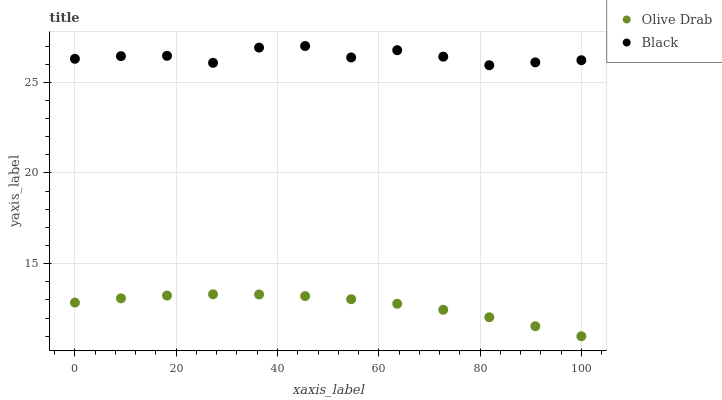Does Olive Drab have the minimum area under the curve?
Answer yes or no. Yes. Does Black have the maximum area under the curve?
Answer yes or no. Yes. Does Olive Drab have the maximum area under the curve?
Answer yes or no. No. Is Olive Drab the smoothest?
Answer yes or no. Yes. Is Black the roughest?
Answer yes or no. Yes. Is Olive Drab the roughest?
Answer yes or no. No. Does Olive Drab have the lowest value?
Answer yes or no. Yes. Does Black have the highest value?
Answer yes or no. Yes. Does Olive Drab have the highest value?
Answer yes or no. No. Is Olive Drab less than Black?
Answer yes or no. Yes. Is Black greater than Olive Drab?
Answer yes or no. Yes. Does Olive Drab intersect Black?
Answer yes or no. No. 